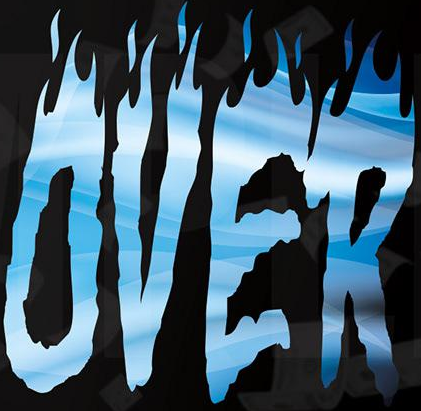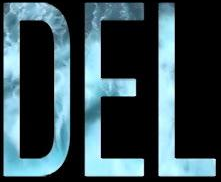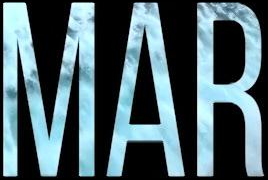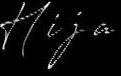What words can you see in these images in sequence, separated by a semicolon? OVER; DEL; MAR; Hija 